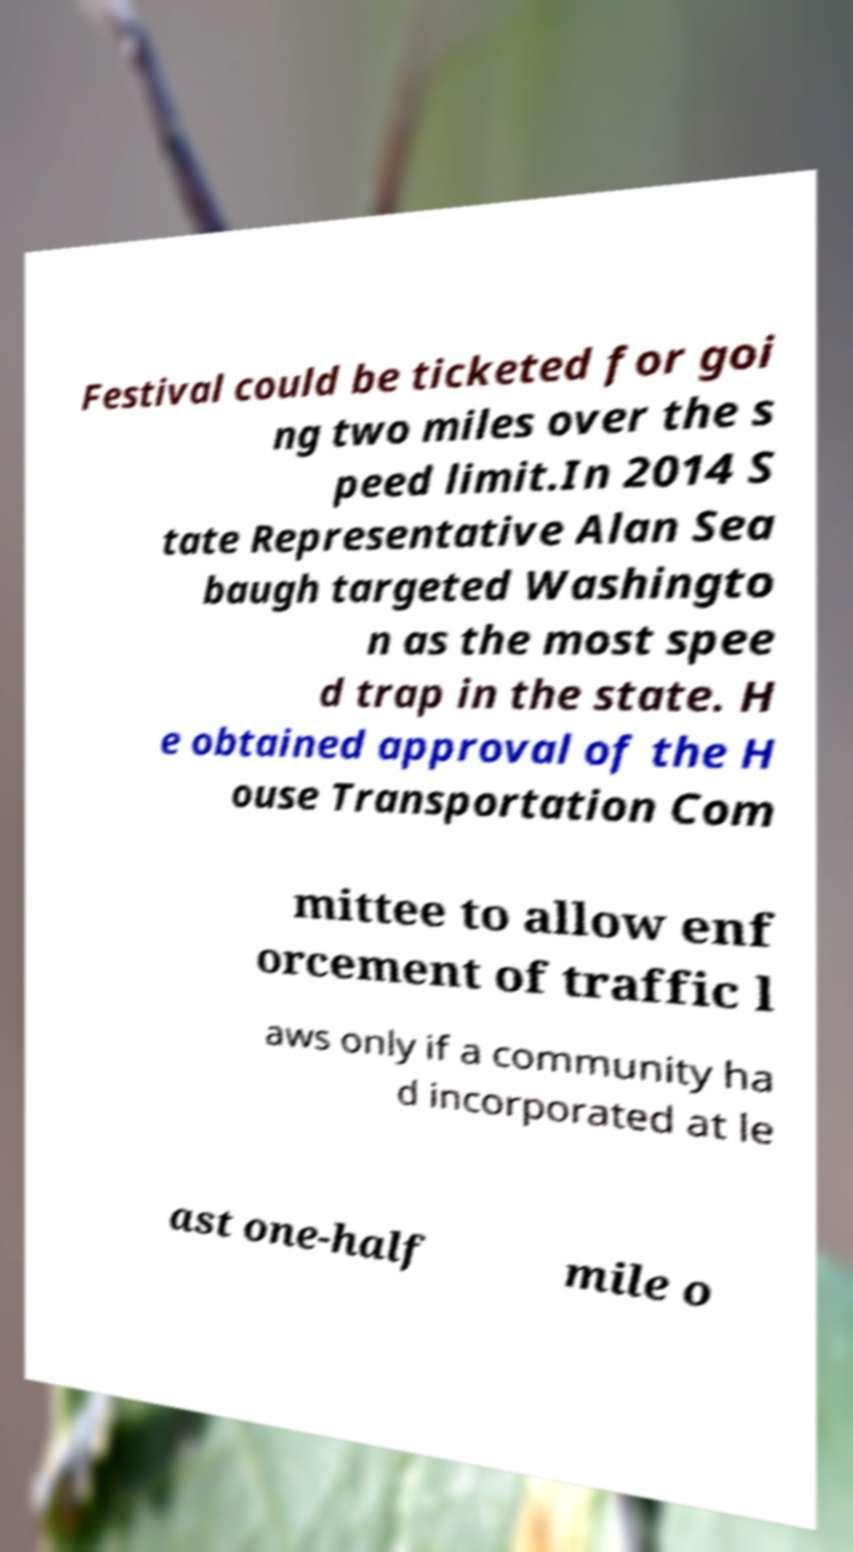For documentation purposes, I need the text within this image transcribed. Could you provide that? Festival could be ticketed for goi ng two miles over the s peed limit.In 2014 S tate Representative Alan Sea baugh targeted Washingto n as the most spee d trap in the state. H e obtained approval of the H ouse Transportation Com mittee to allow enf orcement of traffic l aws only if a community ha d incorporated at le ast one-half mile o 